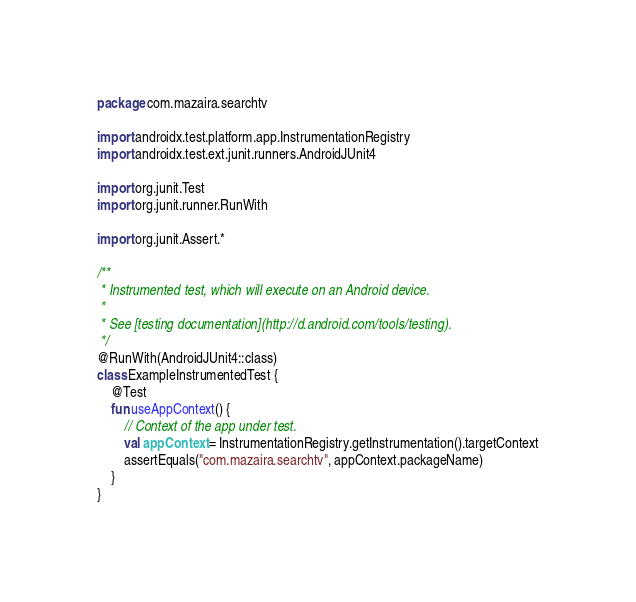<code> <loc_0><loc_0><loc_500><loc_500><_Kotlin_>package com.mazaira.searchtv

import androidx.test.platform.app.InstrumentationRegistry
import androidx.test.ext.junit.runners.AndroidJUnit4

import org.junit.Test
import org.junit.runner.RunWith

import org.junit.Assert.*

/**
 * Instrumented test, which will execute on an Android device.
 *
 * See [testing documentation](http://d.android.com/tools/testing).
 */
@RunWith(AndroidJUnit4::class)
class ExampleInstrumentedTest {
    @Test
    fun useAppContext() {
        // Context of the app under test.
        val appContext = InstrumentationRegistry.getInstrumentation().targetContext
        assertEquals("com.mazaira.searchtv", appContext.packageName)
    }
}</code> 